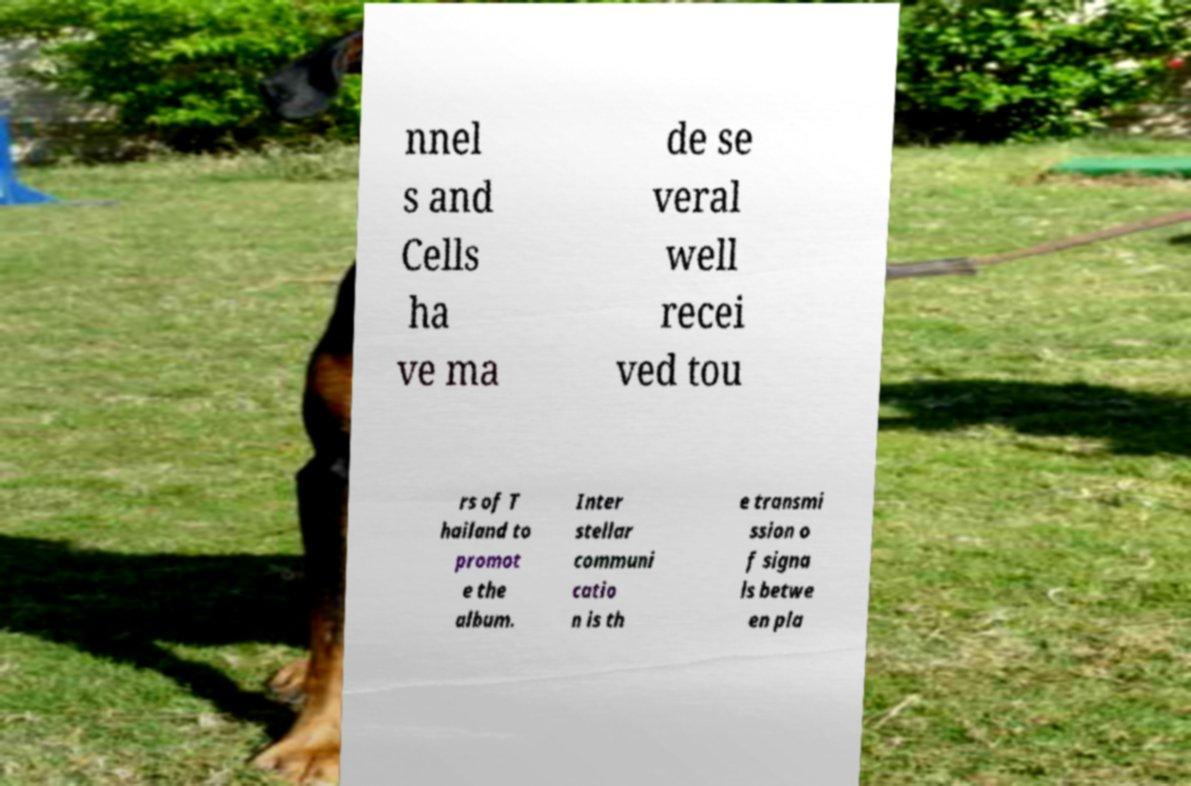Can you read and provide the text displayed in the image?This photo seems to have some interesting text. Can you extract and type it out for me? nnel s and Cells ha ve ma de se veral well recei ved tou rs of T hailand to promot e the album. Inter stellar communi catio n is th e transmi ssion o f signa ls betwe en pla 